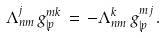<formula> <loc_0><loc_0><loc_500><loc_500>\Lambda ^ { j } _ { n m } \, g ^ { m k } _ { | p } \, = \, - \Lambda ^ { k } _ { n m } \, g ^ { m j } _ { | p } \, .</formula> 